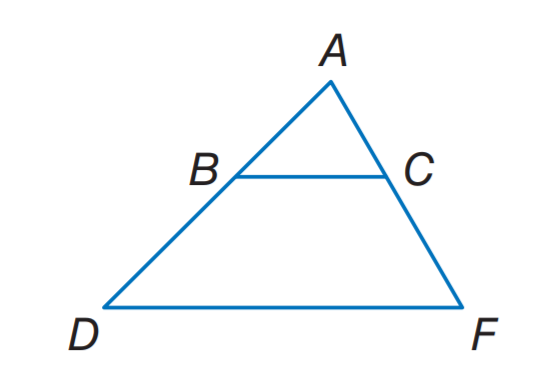Answer the mathemtical geometry problem and directly provide the correct option letter.
Question: B C \parallel D F. A C = 15, B D = 3 x - 2, C F = 3 x + 2, and A B = 12. Find x.
Choices: A: 3 B: 4 C: 5 D: 6 D 